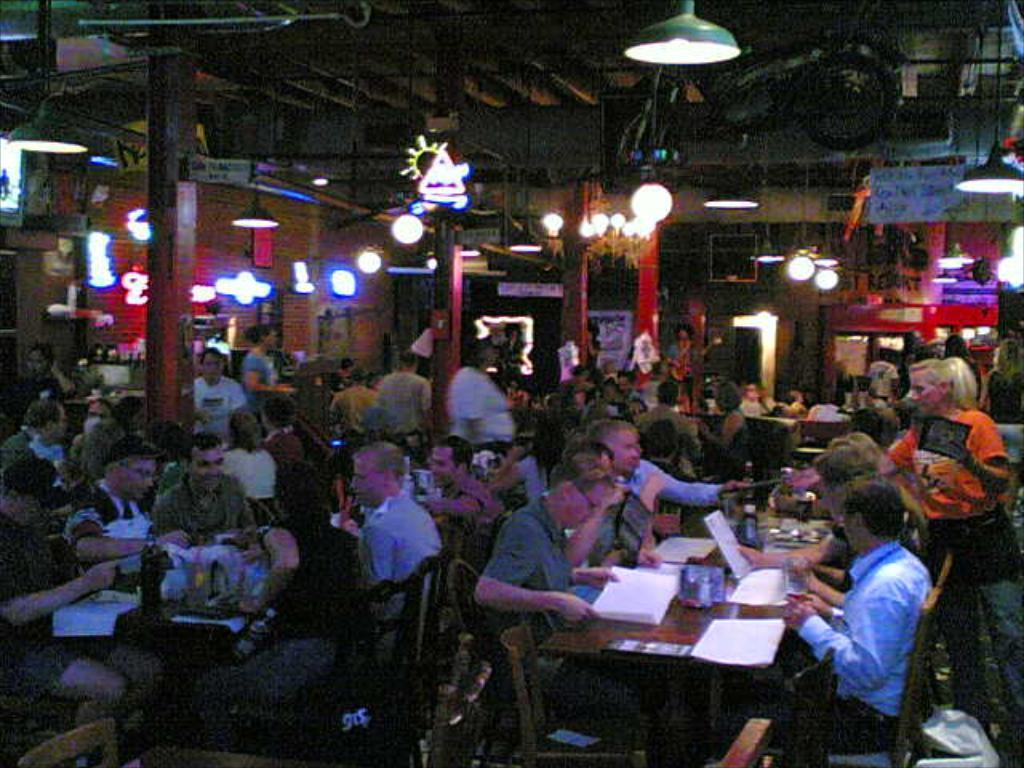How many people can be seen in the image? There are many people in the image. What are the people doing in the image? The people are sitting in a place. What type of furniture is present in the image? There are many tables and chairs in the image. Can you see any deer playing in the background of the image? There are no deer or any play-related activities visible in the image. 